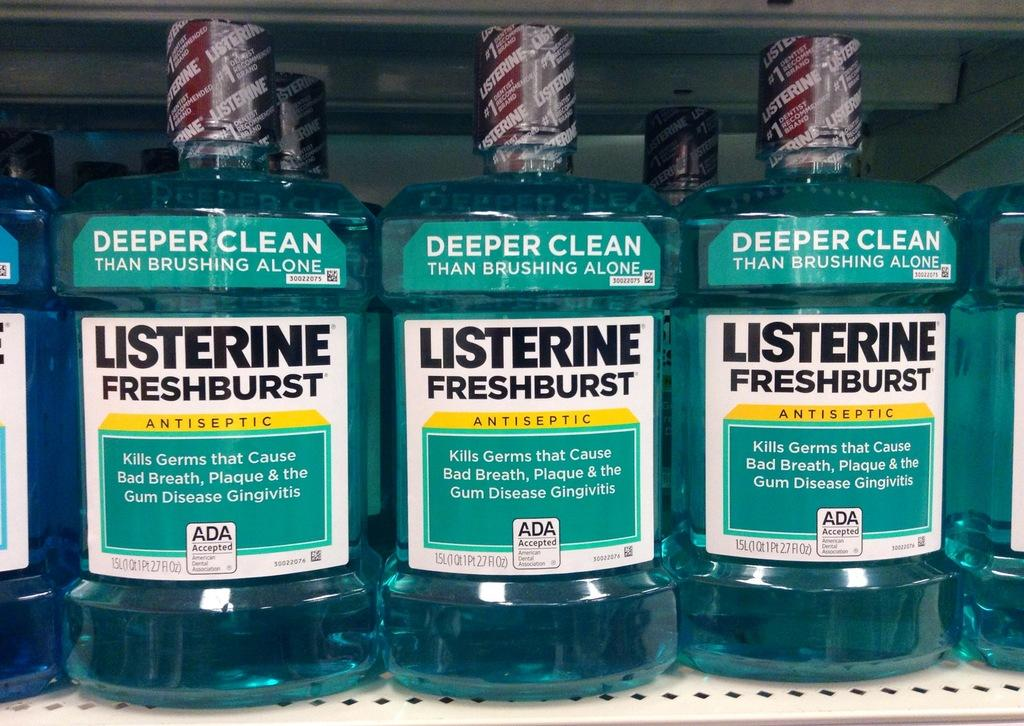Provide a one-sentence caption for the provided image. Three bottles of liquid with the word Listerine on it. 